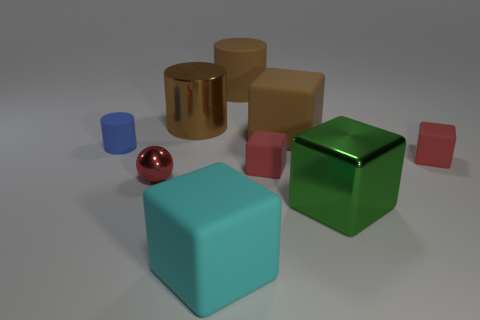What number of things are brown matte objects or things in front of the brown matte cylinder?
Offer a very short reply. 9. There is a large cylinder that is made of the same material as the blue thing; what is its color?
Ensure brevity in your answer.  Brown. How many large brown cylinders are the same material as the blue object?
Give a very brief answer. 1. What number of red things are there?
Provide a succinct answer. 3. There is a large matte block behind the green metallic thing; is it the same color as the big metal thing behind the small red shiny ball?
Keep it short and to the point. Yes. There is a small red metal sphere; what number of tiny objects are to the left of it?
Your answer should be compact. 1. What material is the other big cylinder that is the same color as the large rubber cylinder?
Make the answer very short. Metal. Are there any brown rubber objects of the same shape as the tiny blue object?
Provide a short and direct response. Yes. Do the big block behind the tiny shiny object and the large cylinder to the left of the large cyan matte block have the same material?
Your response must be concise. No. There is a red thing that is left of the big brown cylinder that is on the right side of the big cylinder on the left side of the cyan thing; what size is it?
Give a very brief answer. Small. 